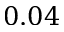<formula> <loc_0><loc_0><loc_500><loc_500>0 . 0 4</formula> 